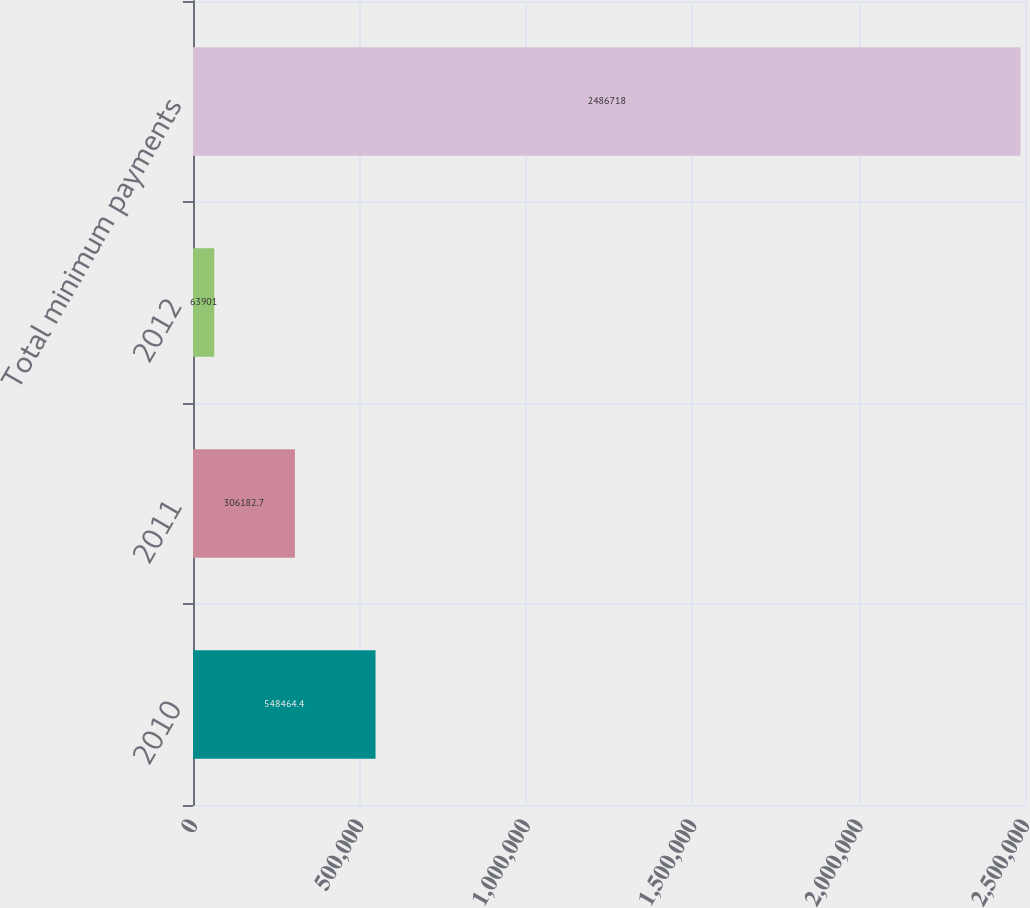Convert chart. <chart><loc_0><loc_0><loc_500><loc_500><bar_chart><fcel>2010<fcel>2011<fcel>2012<fcel>Total minimum payments<nl><fcel>548464<fcel>306183<fcel>63901<fcel>2.48672e+06<nl></chart> 